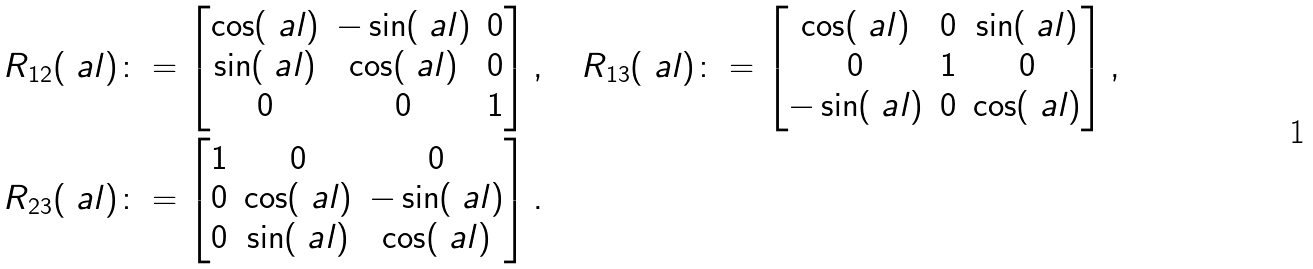Convert formula to latex. <formula><loc_0><loc_0><loc_500><loc_500>R _ { 1 2 } ( \ a l ) & \colon = \begin{bmatrix} \cos ( \ a l ) & - \sin ( \ a l ) & 0 \\ \sin ( \ a l ) & \cos ( \ a l ) & 0 \\ 0 & 0 & 1 \end{bmatrix} , \quad R _ { 1 3 } ( \ a l ) \colon = \begin{bmatrix} \cos ( \ a l ) & 0 & \sin ( \ a l ) \\ 0 & 1 & 0 \\ - \sin ( \ a l ) & 0 & \cos ( \ a l ) \end{bmatrix} , \\ R _ { 2 3 } ( \ a l ) & \colon = \begin{bmatrix} 1 & 0 & 0 \\ 0 & \cos ( \ a l ) & - \sin ( \ a l ) \\ 0 & \sin ( \ a l ) & \cos ( \ a l ) \end{bmatrix} .</formula> 